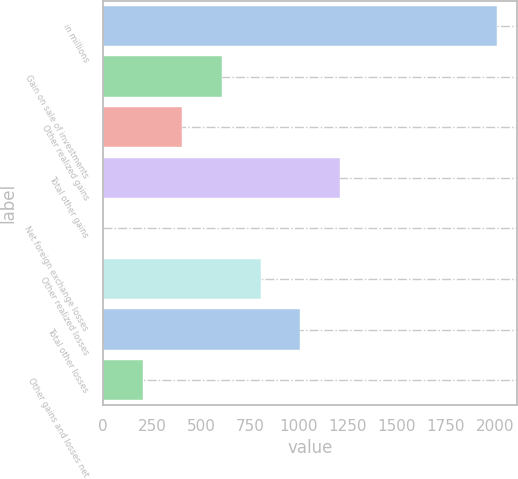Convert chart. <chart><loc_0><loc_0><loc_500><loc_500><bar_chart><fcel>in millions<fcel>Gain on sale of investments<fcel>Other realized gains<fcel>Total other gains<fcel>Net foreign exchange losses<fcel>Other realized losses<fcel>Total other losses<fcel>Other gains and losses net<nl><fcel>2013<fcel>604.32<fcel>403.08<fcel>1208.04<fcel>0.6<fcel>805.56<fcel>1006.8<fcel>201.84<nl></chart> 